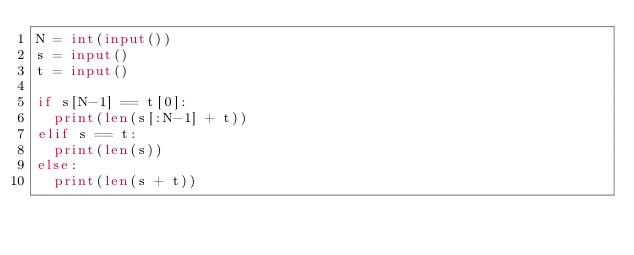<code> <loc_0><loc_0><loc_500><loc_500><_Python_>N = int(input())
s = input()
t = input()

if s[N-1] == t[0]:
  print(len(s[:N-1] + t))
elif s == t:
  print(len(s))
else:
  print(len(s + t))</code> 